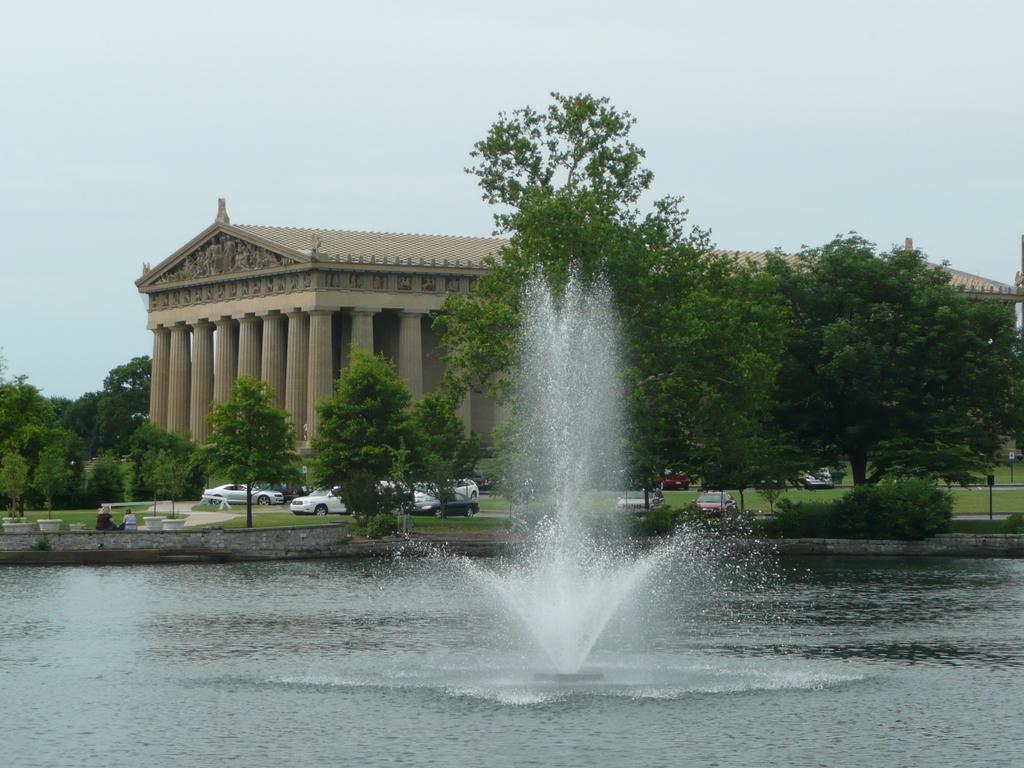Can you describe this image briefly? In this image there is the water. In the center of the water there is a fountain. In the background there is a building. In front of the building there are cars parked. There are trees, plants and grass on the ground. At the top there is the sky. 